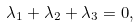Convert formula to latex. <formula><loc_0><loc_0><loc_500><loc_500>\lambda _ { 1 } + \lambda _ { 2 } + \lambda _ { 3 } = 0 ,</formula> 